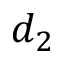Convert formula to latex. <formula><loc_0><loc_0><loc_500><loc_500>d _ { 2 }</formula> 